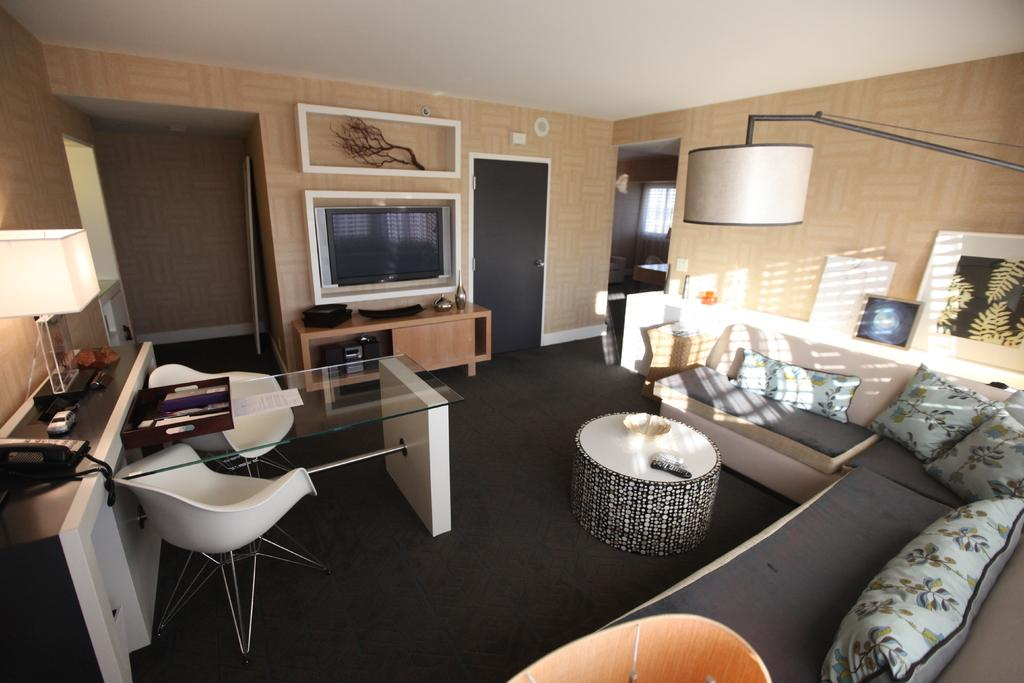What type of furniture is present in the image? There is a couch and a table in the image. What is located to the left of the table? There is a lamp to the left of the table. What can be found on the table? There are objects on the table. What is visible in the background of the image? There is a television and frames attached to the wall in the background. What type of canvas is being used as a boundary in the image? There is no canvas or boundary present in the image. Can you provide an example of an object on the table in the image? It is impossible to provide an example of an object on the table without knowing the specific items present in the image. 